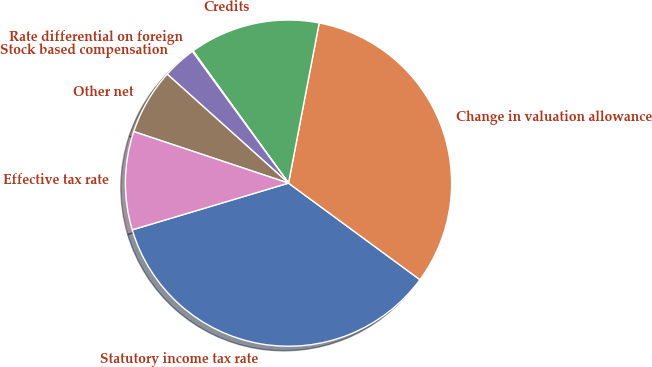Convert chart to OTSL. <chart><loc_0><loc_0><loc_500><loc_500><pie_chart><fcel>Statutory income tax rate<fcel>Change in valuation allowance<fcel>Credits<fcel>Rate differential on foreign<fcel>Stock based compensation<fcel>Other net<fcel>Effective tax rate<nl><fcel>35.29%<fcel>32.07%<fcel>12.96%<fcel>0.09%<fcel>3.31%<fcel>6.53%<fcel>9.74%<nl></chart> 